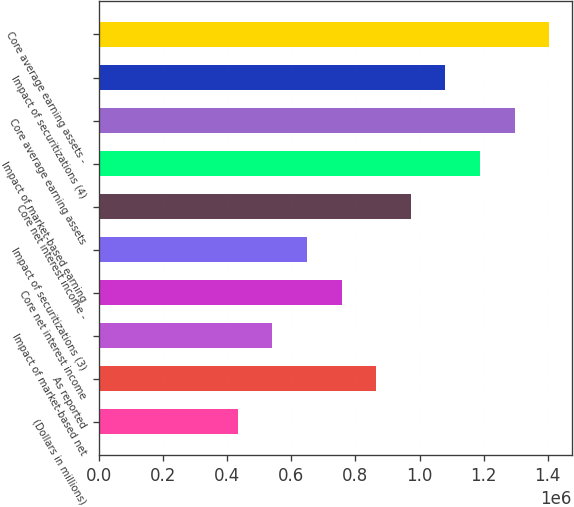<chart> <loc_0><loc_0><loc_500><loc_500><bar_chart><fcel>(Dollars in millions)<fcel>As reported<fcel>Impact of market-based net<fcel>Core net interest income<fcel>Impact of securitizations (3)<fcel>Core net interest income -<fcel>Impact of market-based earning<fcel>Core average earning assets<fcel>Impact of securitizations (4)<fcel>Core average earning assets -<nl><fcel>432391<fcel>864781<fcel>540488<fcel>756683<fcel>648586<fcel>972878<fcel>1.18907e+06<fcel>1.29717e+06<fcel>1.08098e+06<fcel>1.40527e+06<nl></chart> 